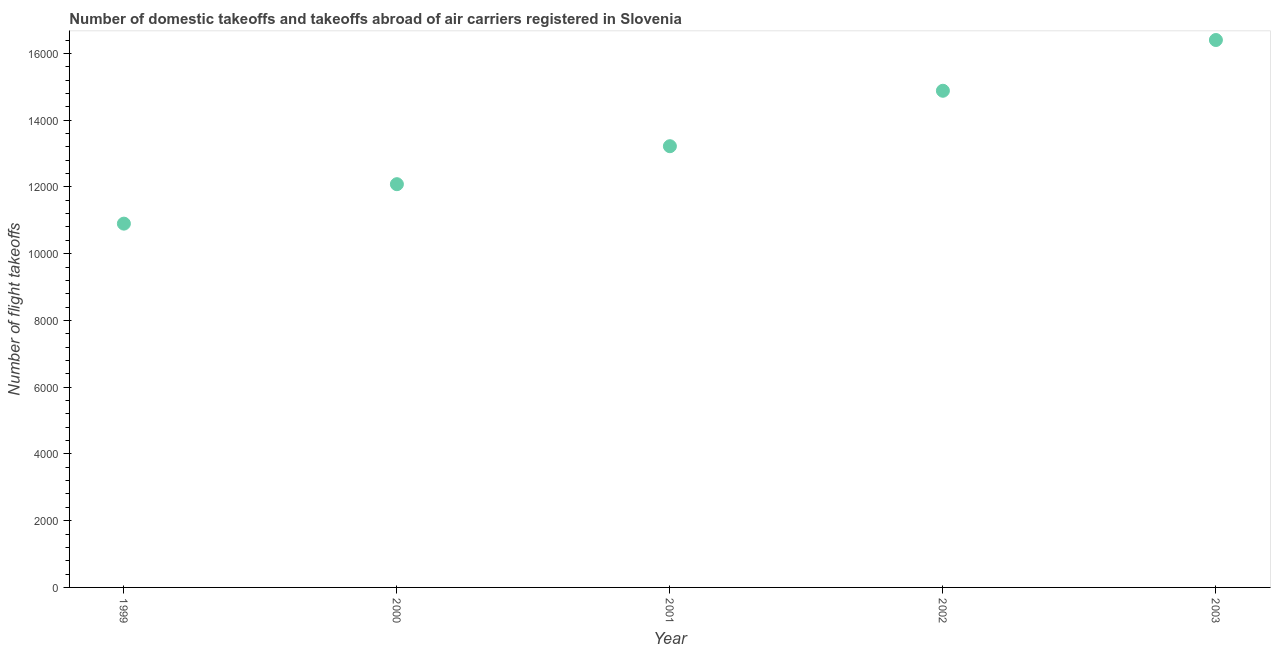What is the number of flight takeoffs in 2000?
Make the answer very short. 1.21e+04. Across all years, what is the maximum number of flight takeoffs?
Provide a short and direct response. 1.64e+04. Across all years, what is the minimum number of flight takeoffs?
Ensure brevity in your answer.  1.09e+04. In which year was the number of flight takeoffs minimum?
Make the answer very short. 1999. What is the sum of the number of flight takeoffs?
Provide a succinct answer. 6.75e+04. What is the difference between the number of flight takeoffs in 1999 and 2003?
Give a very brief answer. -5502. What is the average number of flight takeoffs per year?
Your answer should be compact. 1.35e+04. What is the median number of flight takeoffs?
Your response must be concise. 1.32e+04. What is the ratio of the number of flight takeoffs in 1999 to that in 2003?
Your answer should be very brief. 0.66. Is the number of flight takeoffs in 1999 less than that in 2002?
Ensure brevity in your answer.  Yes. What is the difference between the highest and the second highest number of flight takeoffs?
Ensure brevity in your answer.  1521. What is the difference between the highest and the lowest number of flight takeoffs?
Ensure brevity in your answer.  5502. Does the number of flight takeoffs monotonically increase over the years?
Ensure brevity in your answer.  Yes. How many dotlines are there?
Your answer should be very brief. 1. What is the difference between two consecutive major ticks on the Y-axis?
Keep it short and to the point. 2000. Does the graph contain any zero values?
Offer a very short reply. No. What is the title of the graph?
Offer a very short reply. Number of domestic takeoffs and takeoffs abroad of air carriers registered in Slovenia. What is the label or title of the Y-axis?
Offer a terse response. Number of flight takeoffs. What is the Number of flight takeoffs in 1999?
Ensure brevity in your answer.  1.09e+04. What is the Number of flight takeoffs in 2000?
Offer a very short reply. 1.21e+04. What is the Number of flight takeoffs in 2001?
Keep it short and to the point. 1.32e+04. What is the Number of flight takeoffs in 2002?
Provide a succinct answer. 1.49e+04. What is the Number of flight takeoffs in 2003?
Make the answer very short. 1.64e+04. What is the difference between the Number of flight takeoffs in 1999 and 2000?
Your answer should be compact. -1182. What is the difference between the Number of flight takeoffs in 1999 and 2001?
Your response must be concise. -2320. What is the difference between the Number of flight takeoffs in 1999 and 2002?
Make the answer very short. -3981. What is the difference between the Number of flight takeoffs in 1999 and 2003?
Keep it short and to the point. -5502. What is the difference between the Number of flight takeoffs in 2000 and 2001?
Your answer should be very brief. -1138. What is the difference between the Number of flight takeoffs in 2000 and 2002?
Give a very brief answer. -2799. What is the difference between the Number of flight takeoffs in 2000 and 2003?
Ensure brevity in your answer.  -4320. What is the difference between the Number of flight takeoffs in 2001 and 2002?
Your response must be concise. -1661. What is the difference between the Number of flight takeoffs in 2001 and 2003?
Your answer should be compact. -3182. What is the difference between the Number of flight takeoffs in 2002 and 2003?
Your response must be concise. -1521. What is the ratio of the Number of flight takeoffs in 1999 to that in 2000?
Offer a terse response. 0.9. What is the ratio of the Number of flight takeoffs in 1999 to that in 2001?
Give a very brief answer. 0.82. What is the ratio of the Number of flight takeoffs in 1999 to that in 2002?
Provide a short and direct response. 0.73. What is the ratio of the Number of flight takeoffs in 1999 to that in 2003?
Give a very brief answer. 0.67. What is the ratio of the Number of flight takeoffs in 2000 to that in 2001?
Offer a terse response. 0.91. What is the ratio of the Number of flight takeoffs in 2000 to that in 2002?
Keep it short and to the point. 0.81. What is the ratio of the Number of flight takeoffs in 2000 to that in 2003?
Offer a terse response. 0.74. What is the ratio of the Number of flight takeoffs in 2001 to that in 2002?
Ensure brevity in your answer.  0.89. What is the ratio of the Number of flight takeoffs in 2001 to that in 2003?
Make the answer very short. 0.81. What is the ratio of the Number of flight takeoffs in 2002 to that in 2003?
Offer a terse response. 0.91. 